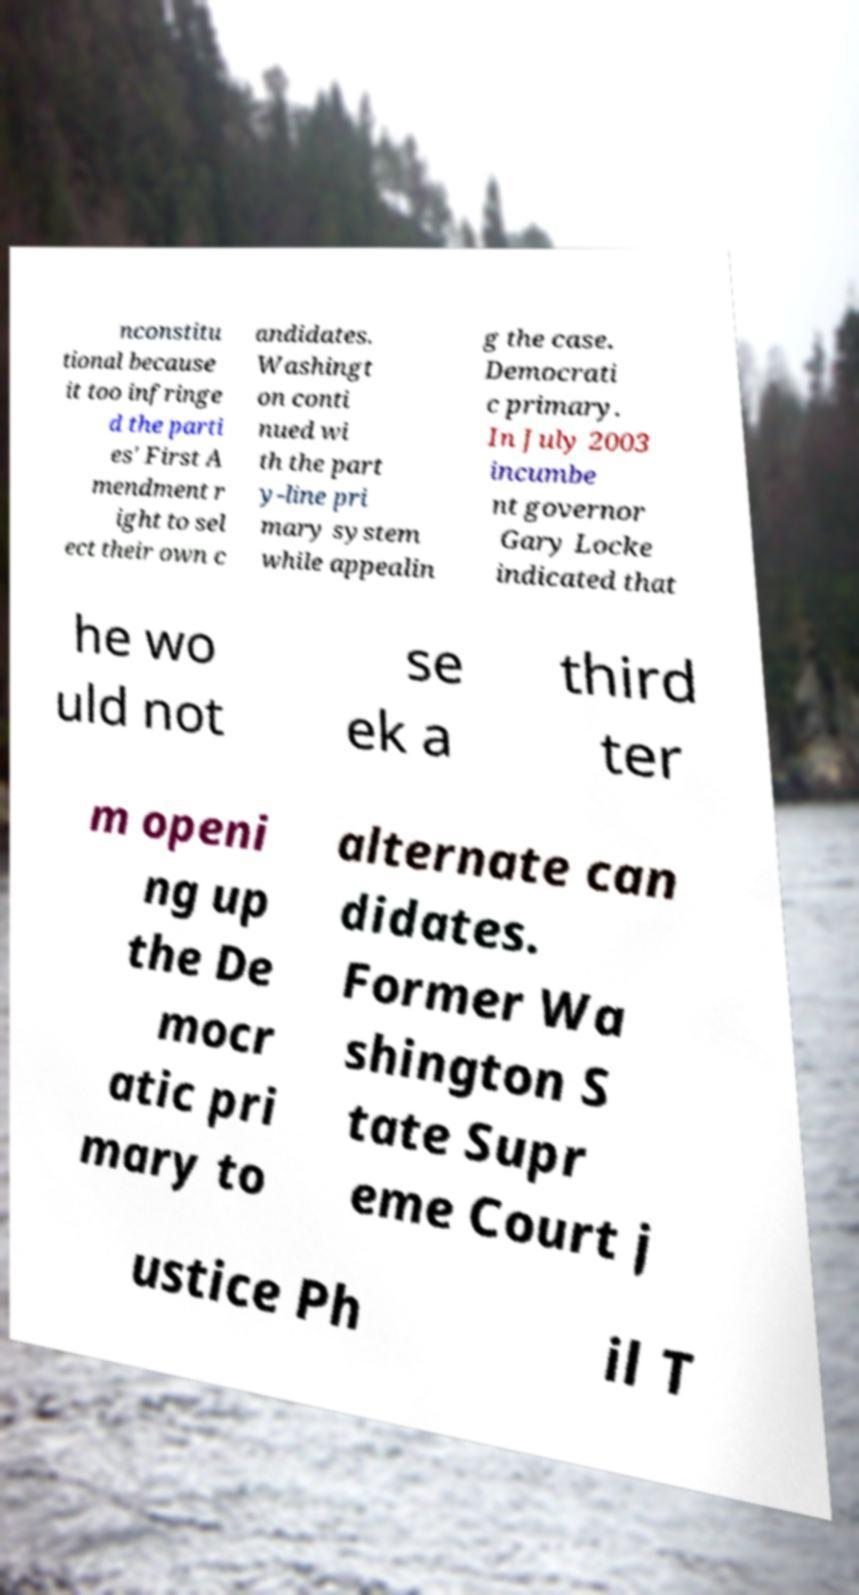Can you accurately transcribe the text from the provided image for me? nconstitu tional because it too infringe d the parti es' First A mendment r ight to sel ect their own c andidates. Washingt on conti nued wi th the part y-line pri mary system while appealin g the case. Democrati c primary. In July 2003 incumbe nt governor Gary Locke indicated that he wo uld not se ek a third ter m openi ng up the De mocr atic pri mary to alternate can didates. Former Wa shington S tate Supr eme Court j ustice Ph il T 